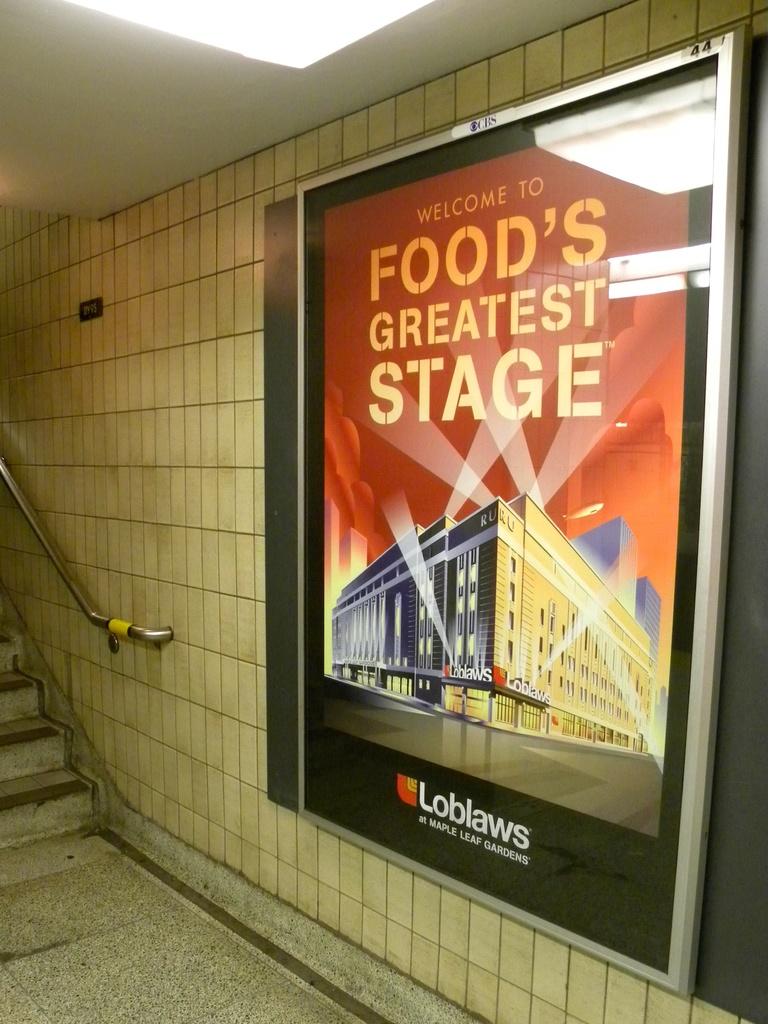What is the food's greatest?
Keep it short and to the point. Stage. What supermarket is this ad for?
Your answer should be compact. Loblaws. 